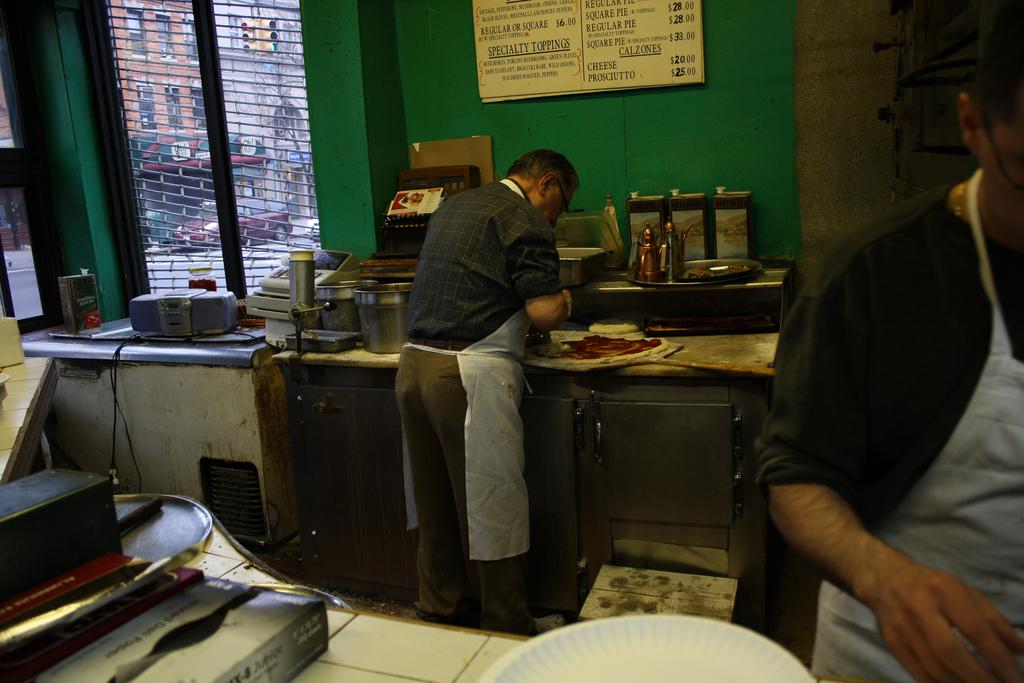Question: how is the counter look like?
Choices:
A. Damaged.
B. Antiquated.
C. Water damaged.
D. Cracked.
Answer with the letter. Answer: A Question: why is the person wearing an apron?
Choices:
A. She's cooking.
B. Hes cooking.
C. He's painting.
D. She's painting.
Answer with the letter. Answer: B Question: when was this photo taken?
Choices:
A. Night time.
B. Dawn.
C. Day time.
D. Dusk.
Answer with the letter. Answer: C Question: where can you see a car?
Choices:
A. In a parking lot.
B. In the driveway.
C. On the highway.
D. Out the window.
Answer with the letter. Answer: D Question: why wouldn't you sit?
Choices:
A. It's wet.
B. It's not comfortable.
C. It's rough.
D. It's sticky.
Answer with the letter. Answer: B Question: why would someone wear an apron?
Choices:
A. To protect their clothes.
B. Cooking food.
C. Painting walls.
D. Keep clean.
Answer with the letter. Answer: A Question: who is shown in the picture?
Choices:
A. Waiters.
B. Chefs.
C. Hostesses.
D. Janitors.
Answer with the letter. Answer: B Question: what color apron does the man have on?
Choices:
A. Brown.
B. Gray.
C. White.
D. Black.
Answer with the letter. Answer: C Question: who is wearing an apron?
Choices:
A. The mannequin.
B. The man.
C. The female chef.
D. The vet assistant.
Answer with the letter. Answer: B Question: where is the radio?
Choices:
A. Next to the computer.
B. Sitting near the counter.
C. In the car console.
D. Installed in the ceiling.
Answer with the letter. Answer: B Question: who is in the picture?
Choices:
A. A man.
B. A boy.
C. An older woman.
D. An older man.
Answer with the letter. Answer: D Question: who is making food?
Choices:
A. A chef.
B. The man wearing brown pants.
C. A cook.
D. A woman.
Answer with the letter. Answer: B 